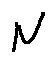<formula> <loc_0><loc_0><loc_500><loc_500>N</formula> 